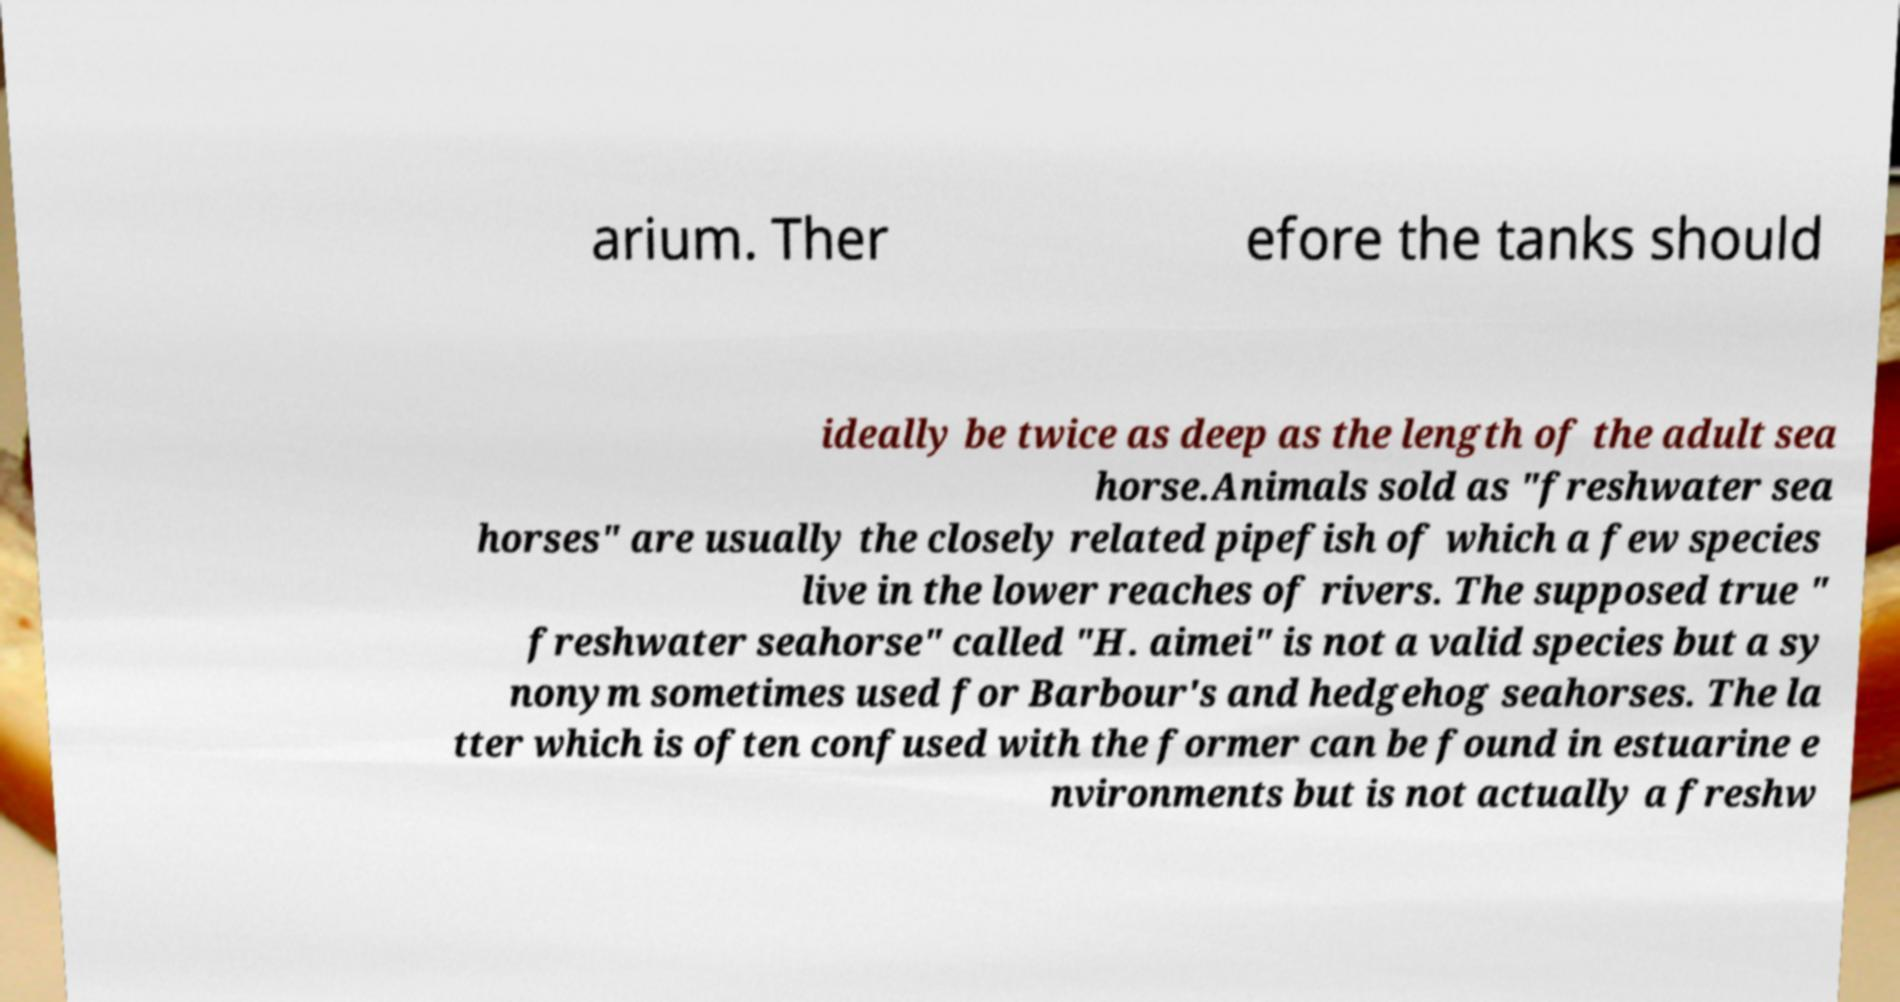Please identify and transcribe the text found in this image. arium. Ther efore the tanks should ideally be twice as deep as the length of the adult sea horse.Animals sold as "freshwater sea horses" are usually the closely related pipefish of which a few species live in the lower reaches of rivers. The supposed true " freshwater seahorse" called "H. aimei" is not a valid species but a sy nonym sometimes used for Barbour's and hedgehog seahorses. The la tter which is often confused with the former can be found in estuarine e nvironments but is not actually a freshw 